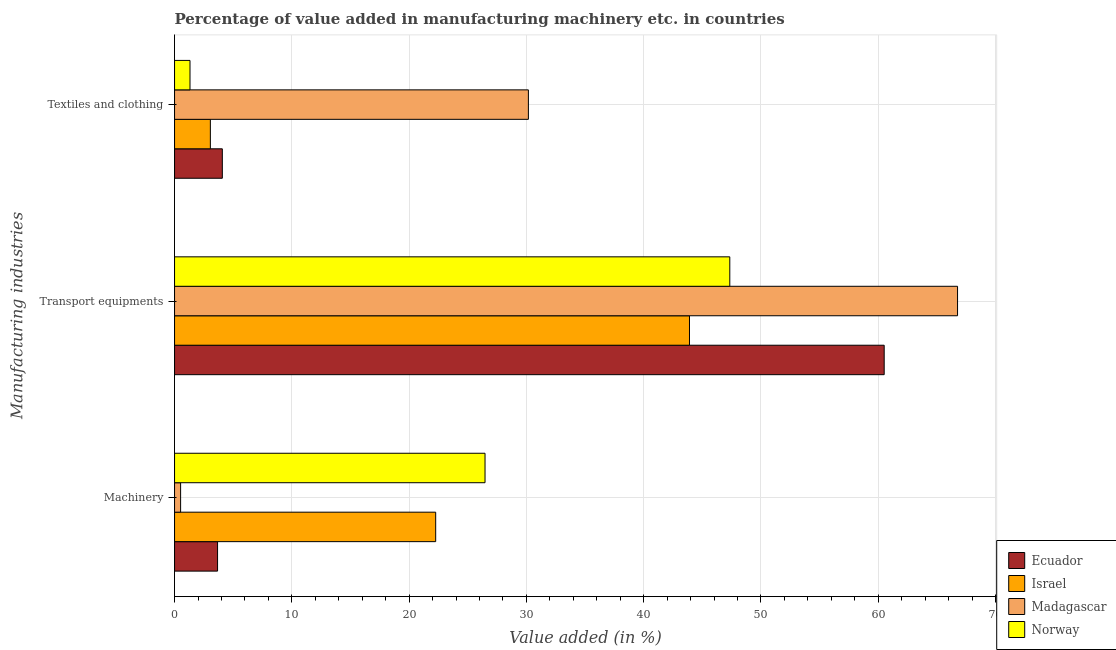How many different coloured bars are there?
Give a very brief answer. 4. How many bars are there on the 1st tick from the top?
Your answer should be very brief. 4. How many bars are there on the 3rd tick from the bottom?
Ensure brevity in your answer.  4. What is the label of the 1st group of bars from the top?
Give a very brief answer. Textiles and clothing. What is the value added in manufacturing transport equipments in Ecuador?
Provide a succinct answer. 60.51. Across all countries, what is the maximum value added in manufacturing transport equipments?
Ensure brevity in your answer.  66.76. Across all countries, what is the minimum value added in manufacturing textile and clothing?
Provide a short and direct response. 1.32. In which country was the value added in manufacturing transport equipments maximum?
Offer a terse response. Madagascar. In which country was the value added in manufacturing textile and clothing minimum?
Make the answer very short. Norway. What is the total value added in manufacturing machinery in the graph?
Keep it short and to the point. 52.93. What is the difference between the value added in manufacturing transport equipments in Madagascar and that in Ecuador?
Ensure brevity in your answer.  6.25. What is the difference between the value added in manufacturing transport equipments in Israel and the value added in manufacturing machinery in Norway?
Provide a succinct answer. 17.43. What is the average value added in manufacturing machinery per country?
Give a very brief answer. 13.23. What is the difference between the value added in manufacturing transport equipments and value added in manufacturing textile and clothing in Israel?
Your answer should be very brief. 40.85. In how many countries, is the value added in manufacturing textile and clothing greater than 42 %?
Ensure brevity in your answer.  0. What is the ratio of the value added in manufacturing transport equipments in Norway to that in Ecuador?
Your answer should be compact. 0.78. Is the difference between the value added in manufacturing machinery in Madagascar and Israel greater than the difference between the value added in manufacturing textile and clothing in Madagascar and Israel?
Offer a terse response. No. What is the difference between the highest and the second highest value added in manufacturing textile and clothing?
Make the answer very short. 26.1. What is the difference between the highest and the lowest value added in manufacturing textile and clothing?
Give a very brief answer. 28.85. Is the sum of the value added in manufacturing machinery in Norway and Madagascar greater than the maximum value added in manufacturing transport equipments across all countries?
Provide a short and direct response. No. What does the 2nd bar from the bottom in Transport equipments represents?
Give a very brief answer. Israel. Is it the case that in every country, the sum of the value added in manufacturing machinery and value added in manufacturing transport equipments is greater than the value added in manufacturing textile and clothing?
Give a very brief answer. Yes. How many countries are there in the graph?
Your answer should be compact. 4. Are the values on the major ticks of X-axis written in scientific E-notation?
Provide a succinct answer. No. Does the graph contain any zero values?
Give a very brief answer. No. Does the graph contain grids?
Your response must be concise. Yes. How many legend labels are there?
Your response must be concise. 4. What is the title of the graph?
Ensure brevity in your answer.  Percentage of value added in manufacturing machinery etc. in countries. What is the label or title of the X-axis?
Keep it short and to the point. Value added (in %). What is the label or title of the Y-axis?
Your answer should be very brief. Manufacturing industries. What is the Value added (in %) in Ecuador in Machinery?
Provide a short and direct response. 3.67. What is the Value added (in %) in Israel in Machinery?
Ensure brevity in your answer.  22.27. What is the Value added (in %) in Madagascar in Machinery?
Ensure brevity in your answer.  0.52. What is the Value added (in %) in Norway in Machinery?
Provide a short and direct response. 26.47. What is the Value added (in %) in Ecuador in Transport equipments?
Your answer should be compact. 60.51. What is the Value added (in %) of Israel in Transport equipments?
Keep it short and to the point. 43.91. What is the Value added (in %) of Madagascar in Transport equipments?
Make the answer very short. 66.76. What is the Value added (in %) in Norway in Transport equipments?
Keep it short and to the point. 47.35. What is the Value added (in %) of Ecuador in Textiles and clothing?
Provide a short and direct response. 4.07. What is the Value added (in %) of Israel in Textiles and clothing?
Offer a terse response. 3.05. What is the Value added (in %) of Madagascar in Textiles and clothing?
Provide a succinct answer. 30.17. What is the Value added (in %) of Norway in Textiles and clothing?
Offer a very short reply. 1.32. Across all Manufacturing industries, what is the maximum Value added (in %) in Ecuador?
Provide a succinct answer. 60.51. Across all Manufacturing industries, what is the maximum Value added (in %) of Israel?
Give a very brief answer. 43.91. Across all Manufacturing industries, what is the maximum Value added (in %) of Madagascar?
Provide a short and direct response. 66.76. Across all Manufacturing industries, what is the maximum Value added (in %) of Norway?
Make the answer very short. 47.35. Across all Manufacturing industries, what is the minimum Value added (in %) in Ecuador?
Provide a succinct answer. 3.67. Across all Manufacturing industries, what is the minimum Value added (in %) of Israel?
Ensure brevity in your answer.  3.05. Across all Manufacturing industries, what is the minimum Value added (in %) of Madagascar?
Make the answer very short. 0.52. Across all Manufacturing industries, what is the minimum Value added (in %) in Norway?
Your answer should be very brief. 1.32. What is the total Value added (in %) in Ecuador in the graph?
Make the answer very short. 68.25. What is the total Value added (in %) in Israel in the graph?
Your response must be concise. 69.23. What is the total Value added (in %) of Madagascar in the graph?
Your answer should be very brief. 97.45. What is the total Value added (in %) in Norway in the graph?
Provide a succinct answer. 75.14. What is the difference between the Value added (in %) in Ecuador in Machinery and that in Transport equipments?
Your answer should be compact. -56.84. What is the difference between the Value added (in %) in Israel in Machinery and that in Transport equipments?
Your answer should be compact. -21.64. What is the difference between the Value added (in %) of Madagascar in Machinery and that in Transport equipments?
Your answer should be very brief. -66.25. What is the difference between the Value added (in %) in Norway in Machinery and that in Transport equipments?
Offer a terse response. -20.87. What is the difference between the Value added (in %) in Ecuador in Machinery and that in Textiles and clothing?
Give a very brief answer. -0.41. What is the difference between the Value added (in %) of Israel in Machinery and that in Textiles and clothing?
Your answer should be very brief. 19.21. What is the difference between the Value added (in %) of Madagascar in Machinery and that in Textiles and clothing?
Offer a very short reply. -29.65. What is the difference between the Value added (in %) in Norway in Machinery and that in Textiles and clothing?
Give a very brief answer. 25.16. What is the difference between the Value added (in %) of Ecuador in Transport equipments and that in Textiles and clothing?
Provide a succinct answer. 56.44. What is the difference between the Value added (in %) in Israel in Transport equipments and that in Textiles and clothing?
Provide a succinct answer. 40.85. What is the difference between the Value added (in %) in Madagascar in Transport equipments and that in Textiles and clothing?
Offer a terse response. 36.59. What is the difference between the Value added (in %) of Norway in Transport equipments and that in Textiles and clothing?
Provide a succinct answer. 46.03. What is the difference between the Value added (in %) of Ecuador in Machinery and the Value added (in %) of Israel in Transport equipments?
Keep it short and to the point. -40.24. What is the difference between the Value added (in %) in Ecuador in Machinery and the Value added (in %) in Madagascar in Transport equipments?
Provide a succinct answer. -63.1. What is the difference between the Value added (in %) of Ecuador in Machinery and the Value added (in %) of Norway in Transport equipments?
Your response must be concise. -43.68. What is the difference between the Value added (in %) of Israel in Machinery and the Value added (in %) of Madagascar in Transport equipments?
Your answer should be very brief. -44.5. What is the difference between the Value added (in %) of Israel in Machinery and the Value added (in %) of Norway in Transport equipments?
Offer a terse response. -25.08. What is the difference between the Value added (in %) in Madagascar in Machinery and the Value added (in %) in Norway in Transport equipments?
Offer a terse response. -46.83. What is the difference between the Value added (in %) of Ecuador in Machinery and the Value added (in %) of Israel in Textiles and clothing?
Your response must be concise. 0.62. What is the difference between the Value added (in %) in Ecuador in Machinery and the Value added (in %) in Madagascar in Textiles and clothing?
Offer a terse response. -26.5. What is the difference between the Value added (in %) in Ecuador in Machinery and the Value added (in %) in Norway in Textiles and clothing?
Ensure brevity in your answer.  2.35. What is the difference between the Value added (in %) of Israel in Machinery and the Value added (in %) of Madagascar in Textiles and clothing?
Keep it short and to the point. -7.9. What is the difference between the Value added (in %) of Israel in Machinery and the Value added (in %) of Norway in Textiles and clothing?
Offer a very short reply. 20.95. What is the difference between the Value added (in %) of Madagascar in Machinery and the Value added (in %) of Norway in Textiles and clothing?
Ensure brevity in your answer.  -0.8. What is the difference between the Value added (in %) in Ecuador in Transport equipments and the Value added (in %) in Israel in Textiles and clothing?
Keep it short and to the point. 57.46. What is the difference between the Value added (in %) of Ecuador in Transport equipments and the Value added (in %) of Madagascar in Textiles and clothing?
Provide a succinct answer. 30.34. What is the difference between the Value added (in %) of Ecuador in Transport equipments and the Value added (in %) of Norway in Textiles and clothing?
Give a very brief answer. 59.19. What is the difference between the Value added (in %) of Israel in Transport equipments and the Value added (in %) of Madagascar in Textiles and clothing?
Offer a terse response. 13.74. What is the difference between the Value added (in %) of Israel in Transport equipments and the Value added (in %) of Norway in Textiles and clothing?
Your response must be concise. 42.59. What is the difference between the Value added (in %) of Madagascar in Transport equipments and the Value added (in %) of Norway in Textiles and clothing?
Your response must be concise. 65.45. What is the average Value added (in %) in Ecuador per Manufacturing industries?
Provide a succinct answer. 22.75. What is the average Value added (in %) in Israel per Manufacturing industries?
Make the answer very short. 23.08. What is the average Value added (in %) of Madagascar per Manufacturing industries?
Your answer should be compact. 32.48. What is the average Value added (in %) in Norway per Manufacturing industries?
Provide a short and direct response. 25.05. What is the difference between the Value added (in %) of Ecuador and Value added (in %) of Israel in Machinery?
Make the answer very short. -18.6. What is the difference between the Value added (in %) of Ecuador and Value added (in %) of Madagascar in Machinery?
Provide a succinct answer. 3.15. What is the difference between the Value added (in %) in Ecuador and Value added (in %) in Norway in Machinery?
Your answer should be very brief. -22.81. What is the difference between the Value added (in %) of Israel and Value added (in %) of Madagascar in Machinery?
Give a very brief answer. 21.75. What is the difference between the Value added (in %) of Israel and Value added (in %) of Norway in Machinery?
Ensure brevity in your answer.  -4.21. What is the difference between the Value added (in %) in Madagascar and Value added (in %) in Norway in Machinery?
Keep it short and to the point. -25.96. What is the difference between the Value added (in %) in Ecuador and Value added (in %) in Israel in Transport equipments?
Provide a succinct answer. 16.6. What is the difference between the Value added (in %) in Ecuador and Value added (in %) in Madagascar in Transport equipments?
Your response must be concise. -6.25. What is the difference between the Value added (in %) of Ecuador and Value added (in %) of Norway in Transport equipments?
Provide a succinct answer. 13.16. What is the difference between the Value added (in %) in Israel and Value added (in %) in Madagascar in Transport equipments?
Your answer should be compact. -22.86. What is the difference between the Value added (in %) of Israel and Value added (in %) of Norway in Transport equipments?
Ensure brevity in your answer.  -3.44. What is the difference between the Value added (in %) in Madagascar and Value added (in %) in Norway in Transport equipments?
Your answer should be very brief. 19.42. What is the difference between the Value added (in %) in Ecuador and Value added (in %) in Israel in Textiles and clothing?
Offer a terse response. 1.02. What is the difference between the Value added (in %) in Ecuador and Value added (in %) in Madagascar in Textiles and clothing?
Your answer should be compact. -26.1. What is the difference between the Value added (in %) in Ecuador and Value added (in %) in Norway in Textiles and clothing?
Give a very brief answer. 2.76. What is the difference between the Value added (in %) in Israel and Value added (in %) in Madagascar in Textiles and clothing?
Give a very brief answer. -27.12. What is the difference between the Value added (in %) in Israel and Value added (in %) in Norway in Textiles and clothing?
Provide a short and direct response. 1.74. What is the difference between the Value added (in %) of Madagascar and Value added (in %) of Norway in Textiles and clothing?
Ensure brevity in your answer.  28.85. What is the ratio of the Value added (in %) of Ecuador in Machinery to that in Transport equipments?
Offer a terse response. 0.06. What is the ratio of the Value added (in %) in Israel in Machinery to that in Transport equipments?
Your answer should be compact. 0.51. What is the ratio of the Value added (in %) in Madagascar in Machinery to that in Transport equipments?
Provide a short and direct response. 0.01. What is the ratio of the Value added (in %) of Norway in Machinery to that in Transport equipments?
Your response must be concise. 0.56. What is the ratio of the Value added (in %) in Ecuador in Machinery to that in Textiles and clothing?
Give a very brief answer. 0.9. What is the ratio of the Value added (in %) in Israel in Machinery to that in Textiles and clothing?
Offer a very short reply. 7.29. What is the ratio of the Value added (in %) in Madagascar in Machinery to that in Textiles and clothing?
Make the answer very short. 0.02. What is the ratio of the Value added (in %) of Norway in Machinery to that in Textiles and clothing?
Provide a succinct answer. 20.1. What is the ratio of the Value added (in %) of Ecuador in Transport equipments to that in Textiles and clothing?
Your answer should be compact. 14.85. What is the ratio of the Value added (in %) of Israel in Transport equipments to that in Textiles and clothing?
Your response must be concise. 14.38. What is the ratio of the Value added (in %) of Madagascar in Transport equipments to that in Textiles and clothing?
Keep it short and to the point. 2.21. What is the ratio of the Value added (in %) in Norway in Transport equipments to that in Textiles and clothing?
Provide a short and direct response. 35.95. What is the difference between the highest and the second highest Value added (in %) in Ecuador?
Provide a short and direct response. 56.44. What is the difference between the highest and the second highest Value added (in %) of Israel?
Your answer should be compact. 21.64. What is the difference between the highest and the second highest Value added (in %) in Madagascar?
Make the answer very short. 36.59. What is the difference between the highest and the second highest Value added (in %) in Norway?
Ensure brevity in your answer.  20.87. What is the difference between the highest and the lowest Value added (in %) of Ecuador?
Keep it short and to the point. 56.84. What is the difference between the highest and the lowest Value added (in %) of Israel?
Provide a short and direct response. 40.85. What is the difference between the highest and the lowest Value added (in %) of Madagascar?
Your response must be concise. 66.25. What is the difference between the highest and the lowest Value added (in %) of Norway?
Your answer should be compact. 46.03. 